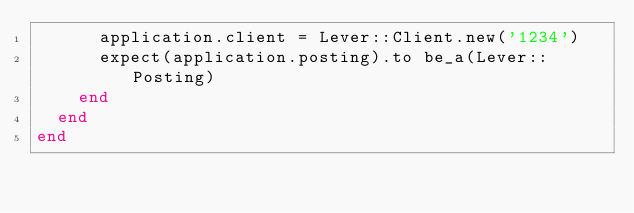Convert code to text. <code><loc_0><loc_0><loc_500><loc_500><_Ruby_>      application.client = Lever::Client.new('1234')
      expect(application.posting).to be_a(Lever::Posting)
    end
  end
end
</code> 